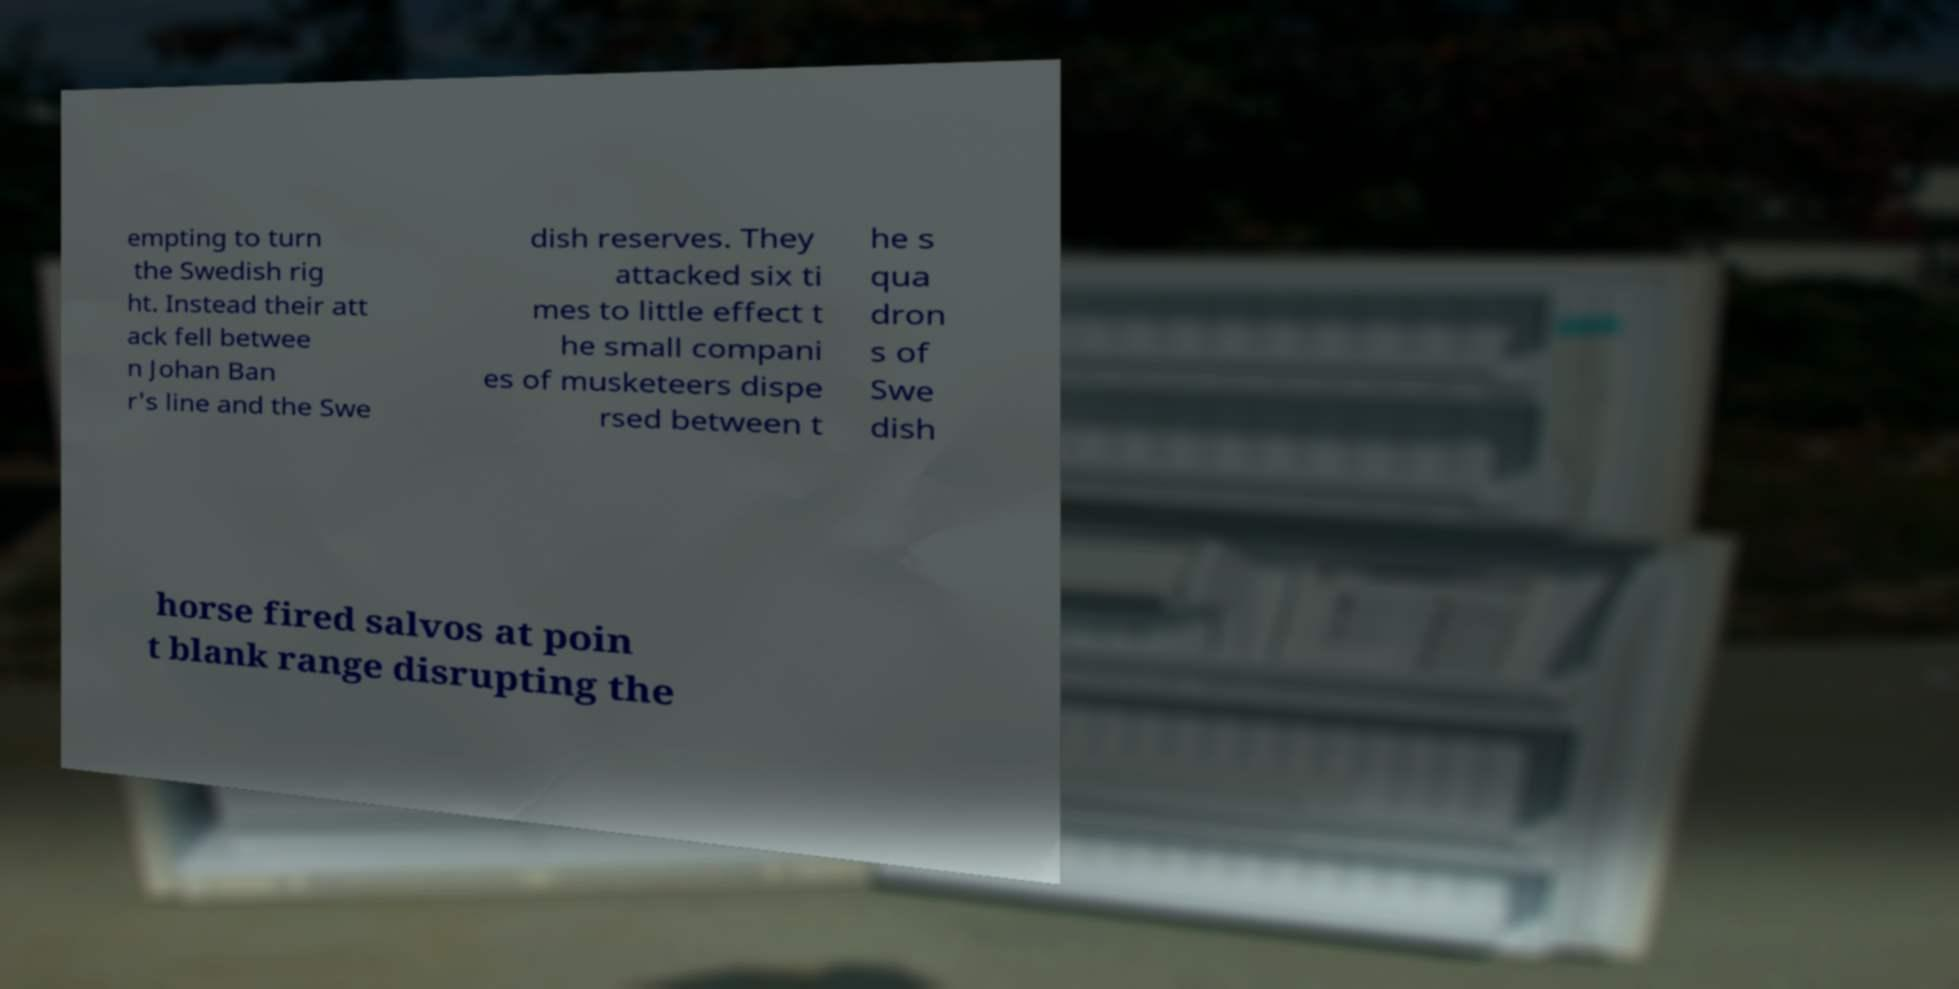Could you extract and type out the text from this image? empting to turn the Swedish rig ht. Instead their att ack fell betwee n Johan Ban r's line and the Swe dish reserves. They attacked six ti mes to little effect t he small compani es of musketeers dispe rsed between t he s qua dron s of Swe dish horse fired salvos at poin t blank range disrupting the 